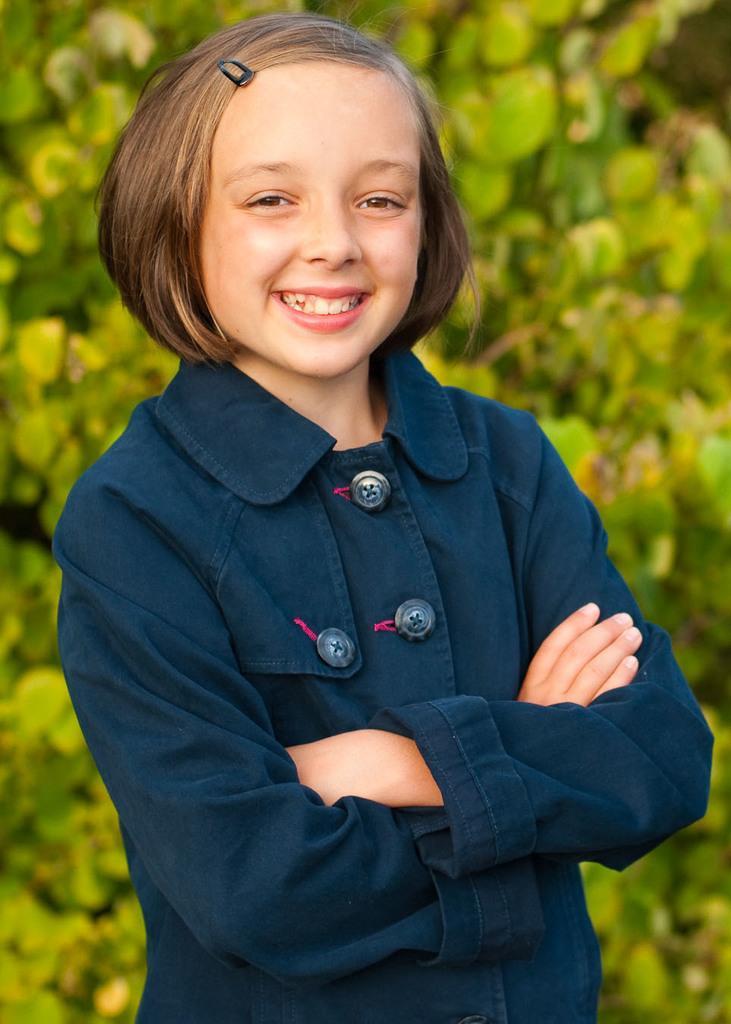Can you describe this image briefly? In this image we can see a girl standing and smiling. In the background there are trees. 